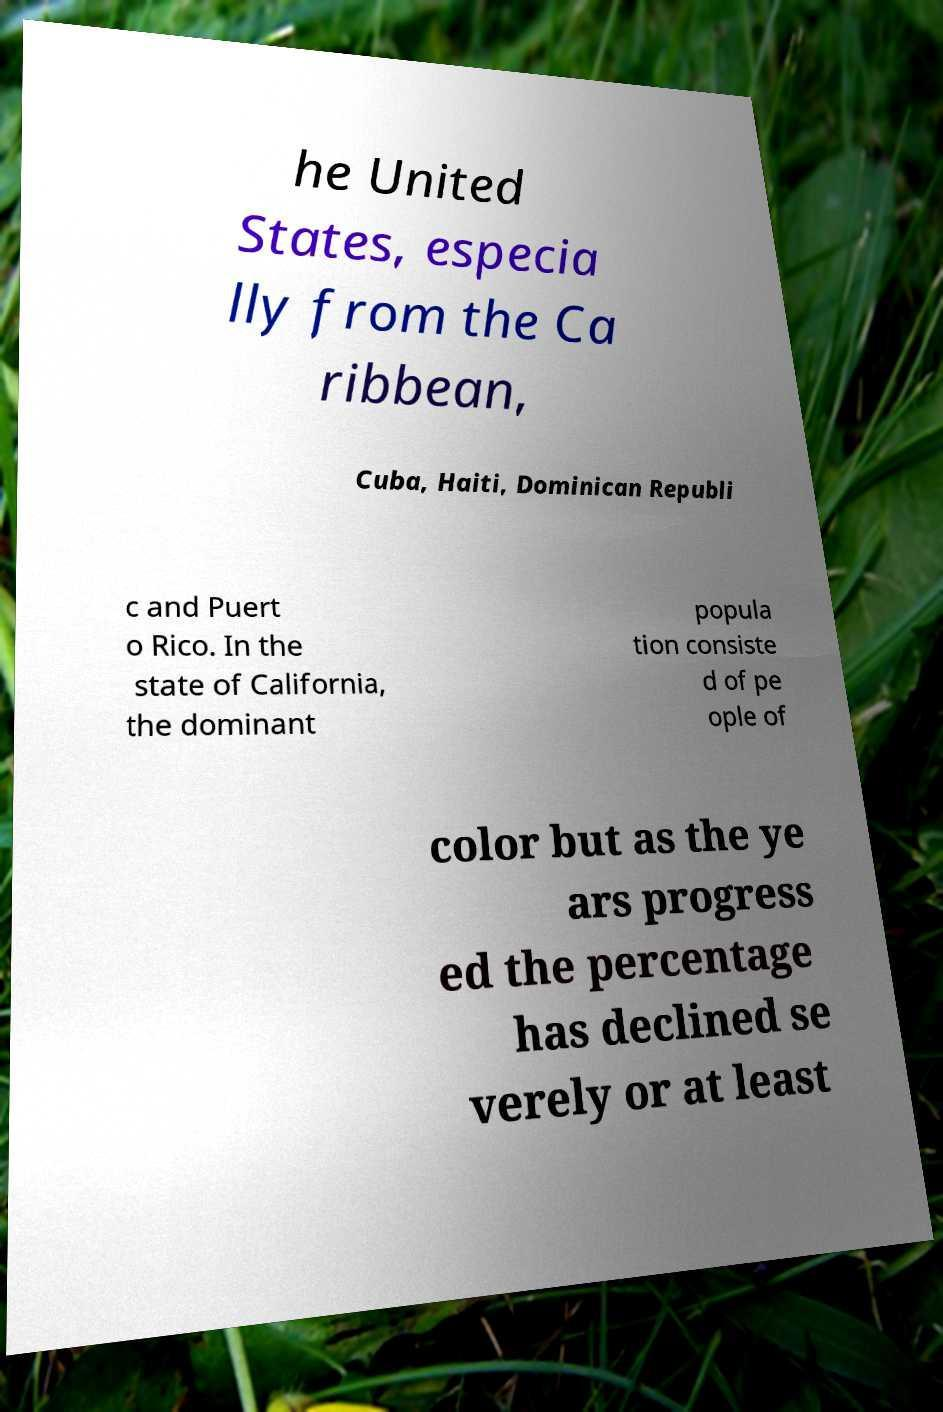Please read and relay the text visible in this image. What does it say? he United States, especia lly from the Ca ribbean, Cuba, Haiti, Dominican Republi c and Puert o Rico. In the state of California, the dominant popula tion consiste d of pe ople of color but as the ye ars progress ed the percentage has declined se verely or at least 